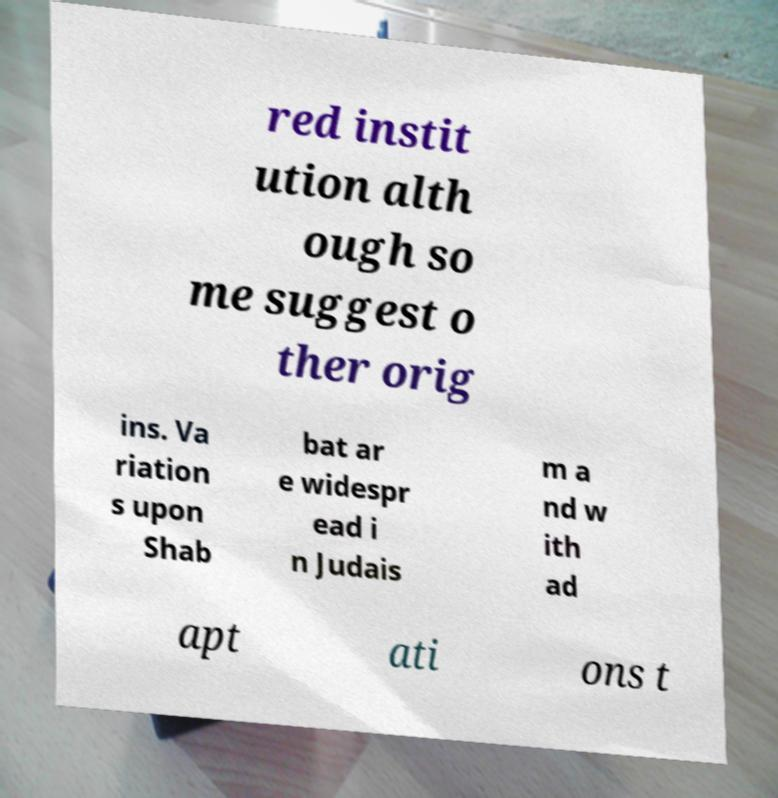Could you extract and type out the text from this image? red instit ution alth ough so me suggest o ther orig ins. Va riation s upon Shab bat ar e widespr ead i n Judais m a nd w ith ad apt ati ons t 